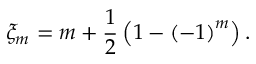Convert formula to latex. <formula><loc_0><loc_0><loc_500><loc_500>\xi _ { m } = m + \frac { 1 } { 2 } \left ( 1 - \left ( - 1 \right ) ^ { m } \right ) .</formula> 